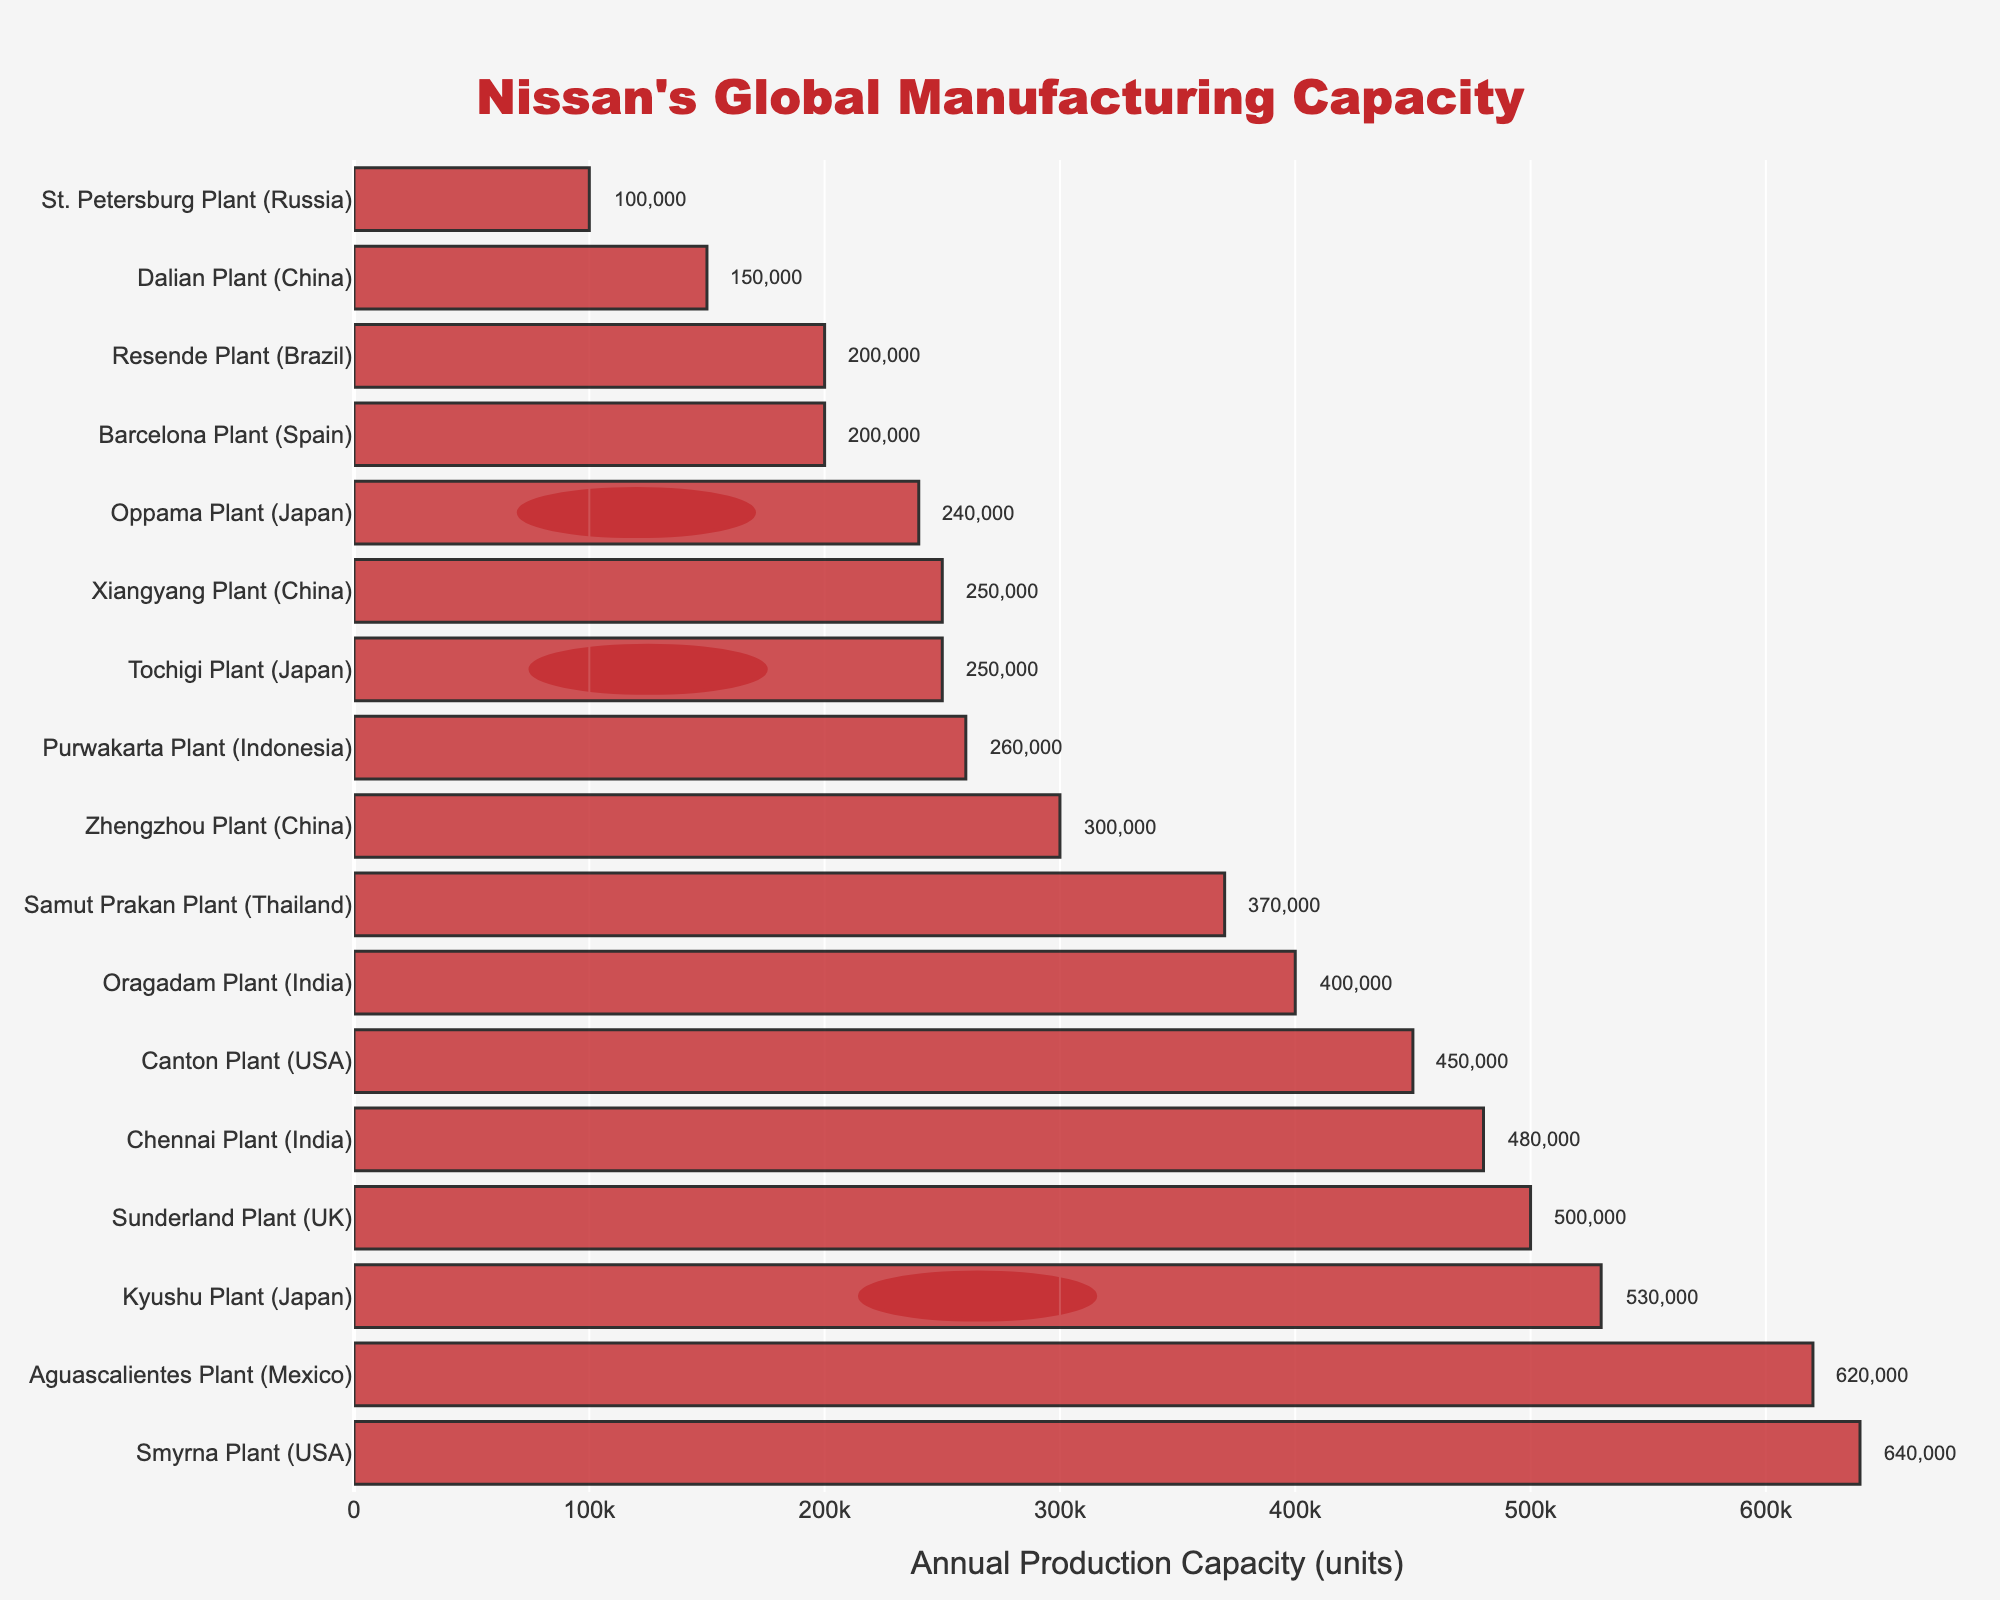What is the annual production capacity of the Smyrna Plant in the USA? Find the bar corresponding to the Smyrna Plant located in the USA. The label next to this bar shows the number of units produced annually.
Answer: 640,000 Which plant has the highest annual production capacity? Look for the longest bar in the chart. The label next to this bar indicates the location with the highest annual production capacity.
Answer: Smyrna Plant (USA) What is the combined annual production capacity of all Nissan facilities in India? Identify and sum the capacities of the Chennai Plant and Oragadam Plant, both located in India. The Chennai Plant produces 480,000 units and the Oragadam Plant produces 400,000 units.
Answer: 880,000 Which Nissan plant in China has a higher production capacity: Zhengzhou Plant or Xiangyang Plant? Compare the lengths of the bars corresponding to Zhengzhou Plant and Xiangyang Plant in China. The Zhengzhou Plant has a capacity of 300,000 units, and the Xiangyang Plant has a capacity of 250,000 units.
Answer: Zhengzhou Plant How much higher is the production capacity of the Aguascalientes Plant in Mexico compared to the Sunderland Plant in the UK? Subtract the annual production capacity of the Sunderland Plant (500,000 units) from that of the Aguascalientes Plant (620,000 units).
Answer: 120,000 Which three locations have the lowest annual production capacities? Identify the three shortest bars in the chart and check their labels. These bars correspond to the St. Petersburg Plant (100,000 units), Dalian Plant (150,000 units), and Barcelona Plant (200,000 units).
Answer: St. Petersburg Plant (Russia), Dalian Plant (China), Barcelona Plant (Spain) What is the average annual production capacity of the Japanese Nissan plants? Add the production capacities of all Japanese plants (Tochigi Plant: 250,000 units, Kyushu Plant: 530,000 units, Oppama Plant: 240,000 units) and divide by the number of plants (3). (250,000 + 530,000 + 240,000) / 3 = 1,020,000 / 3
Answer: 340,000 How does the color pattern help in identifying Japanese plants in the chart? Look at the visual pattern on the bars corresponding to Japanese plants. They have a Japanese flag pattern (white with a red circle). This visual aid helps distinguish Japanese plants from others.
Answer: Japanese flag pattern 